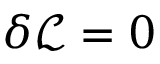<formula> <loc_0><loc_0><loc_500><loc_500>\delta \mathcal { L } = 0</formula> 